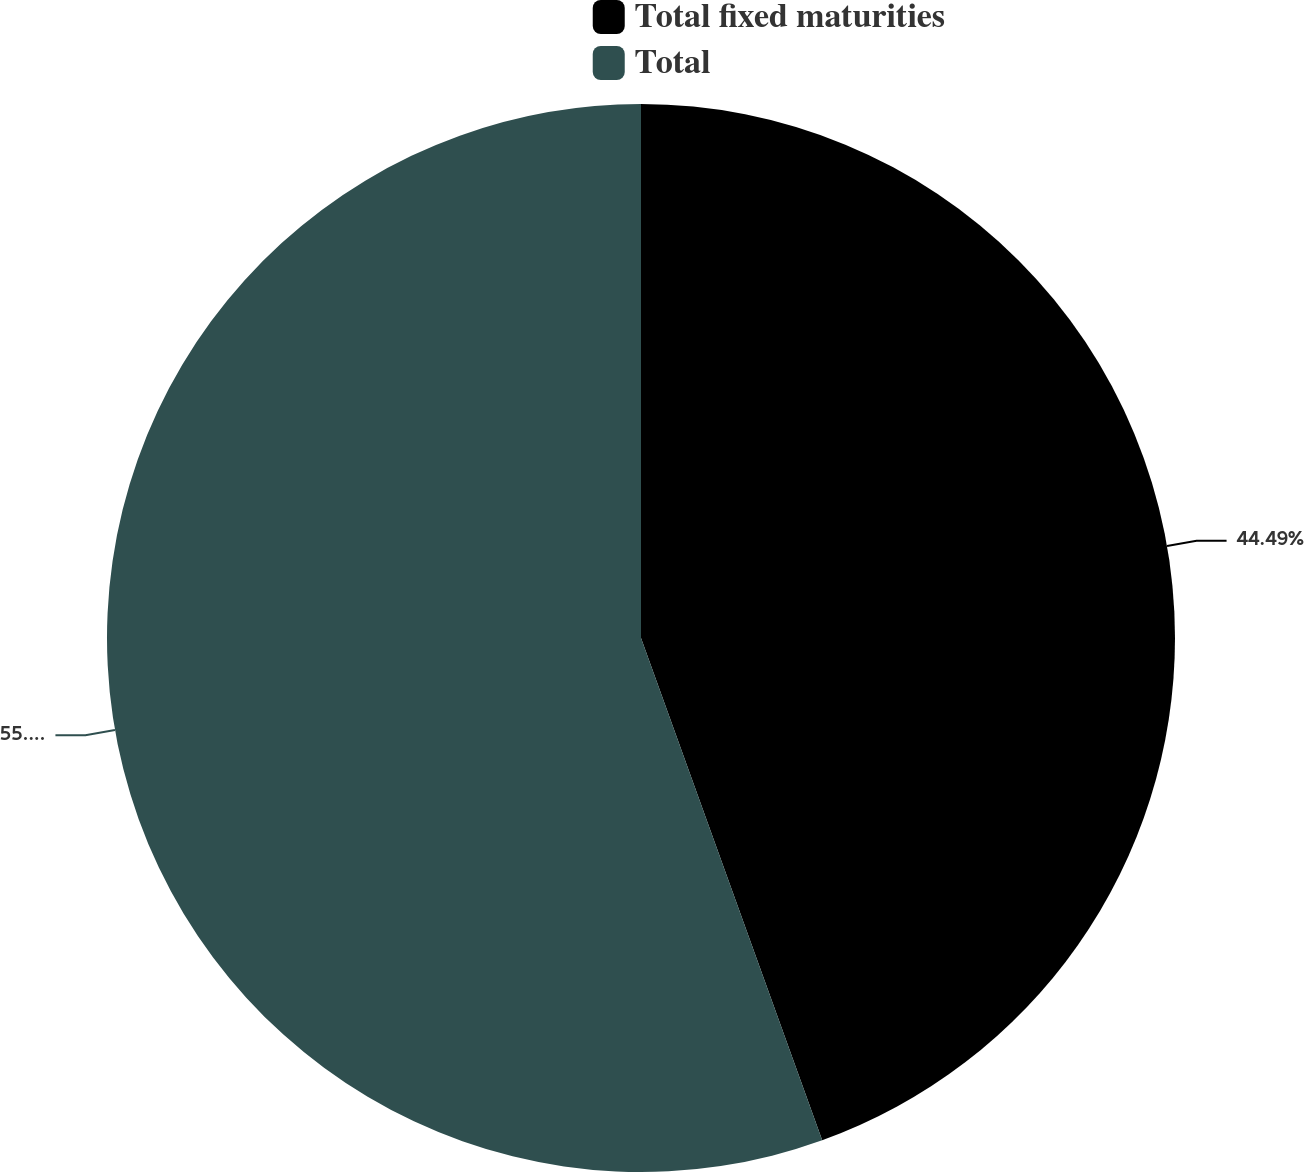<chart> <loc_0><loc_0><loc_500><loc_500><pie_chart><fcel>Total fixed maturities<fcel>Total<nl><fcel>44.49%<fcel>55.51%<nl></chart> 